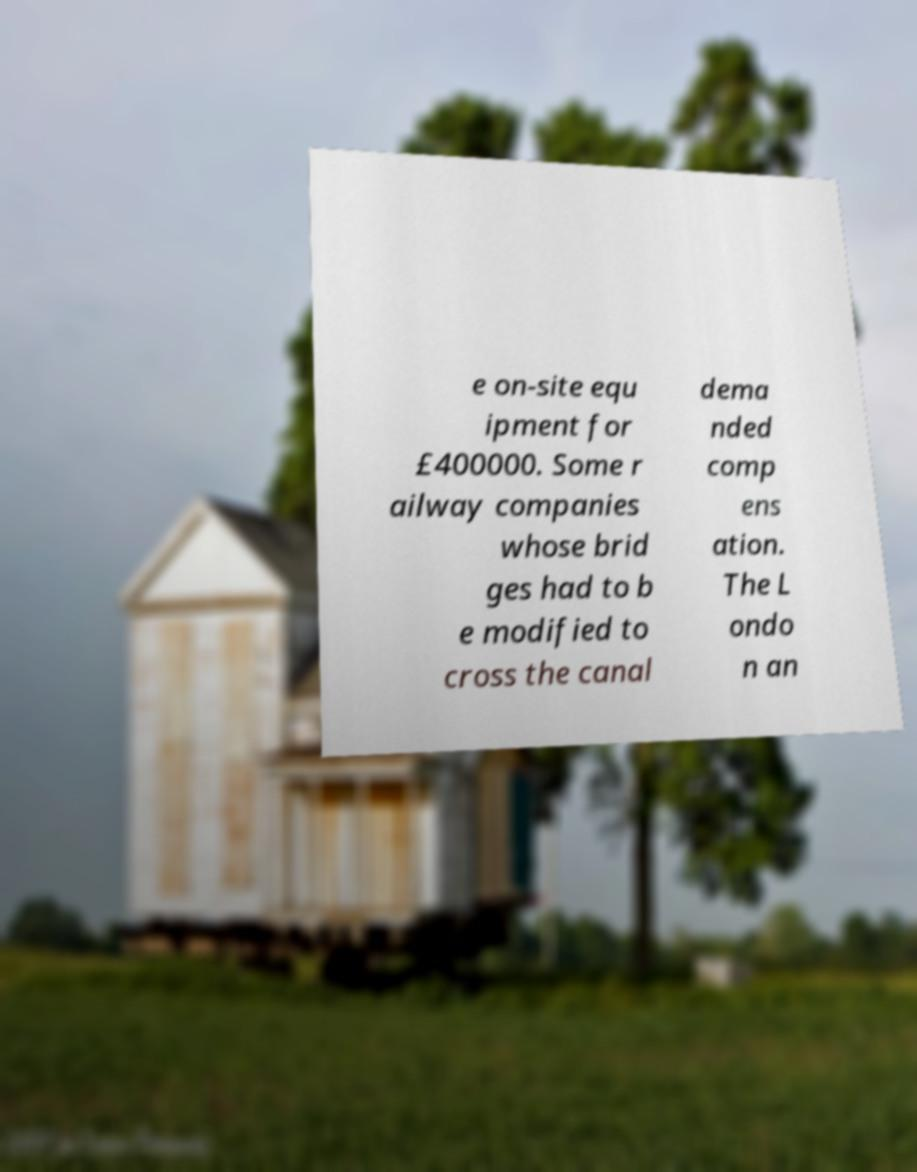For documentation purposes, I need the text within this image transcribed. Could you provide that? e on-site equ ipment for £400000. Some r ailway companies whose brid ges had to b e modified to cross the canal dema nded comp ens ation. The L ondo n an 